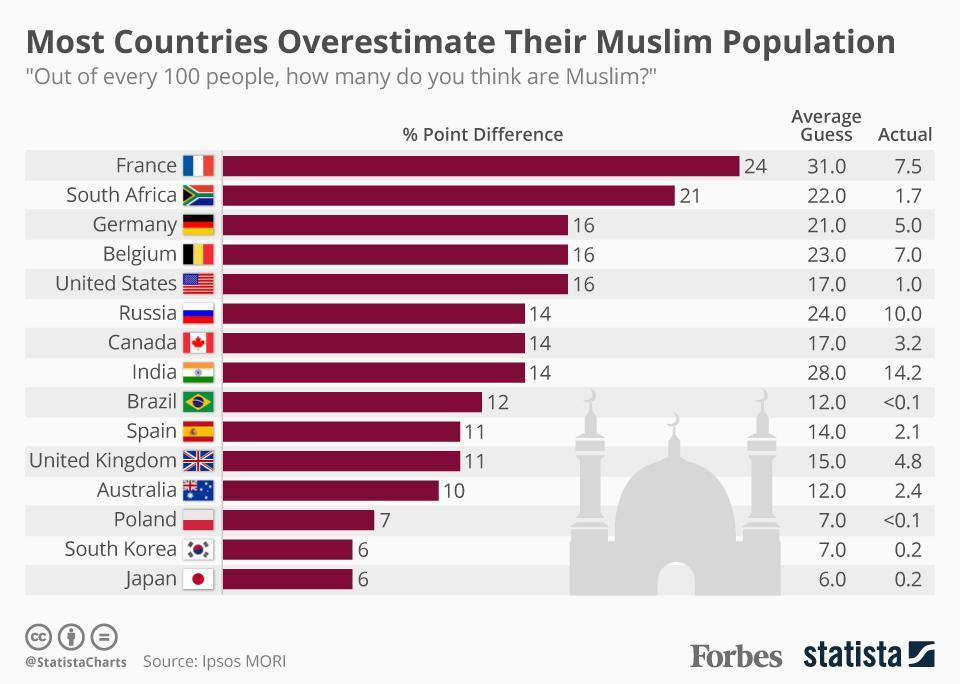Which all countries have the percentage point difference as 6?
Answer the question with a short phrase. South Korea, Japan How many countries have the percentage point difference as 6? 2 